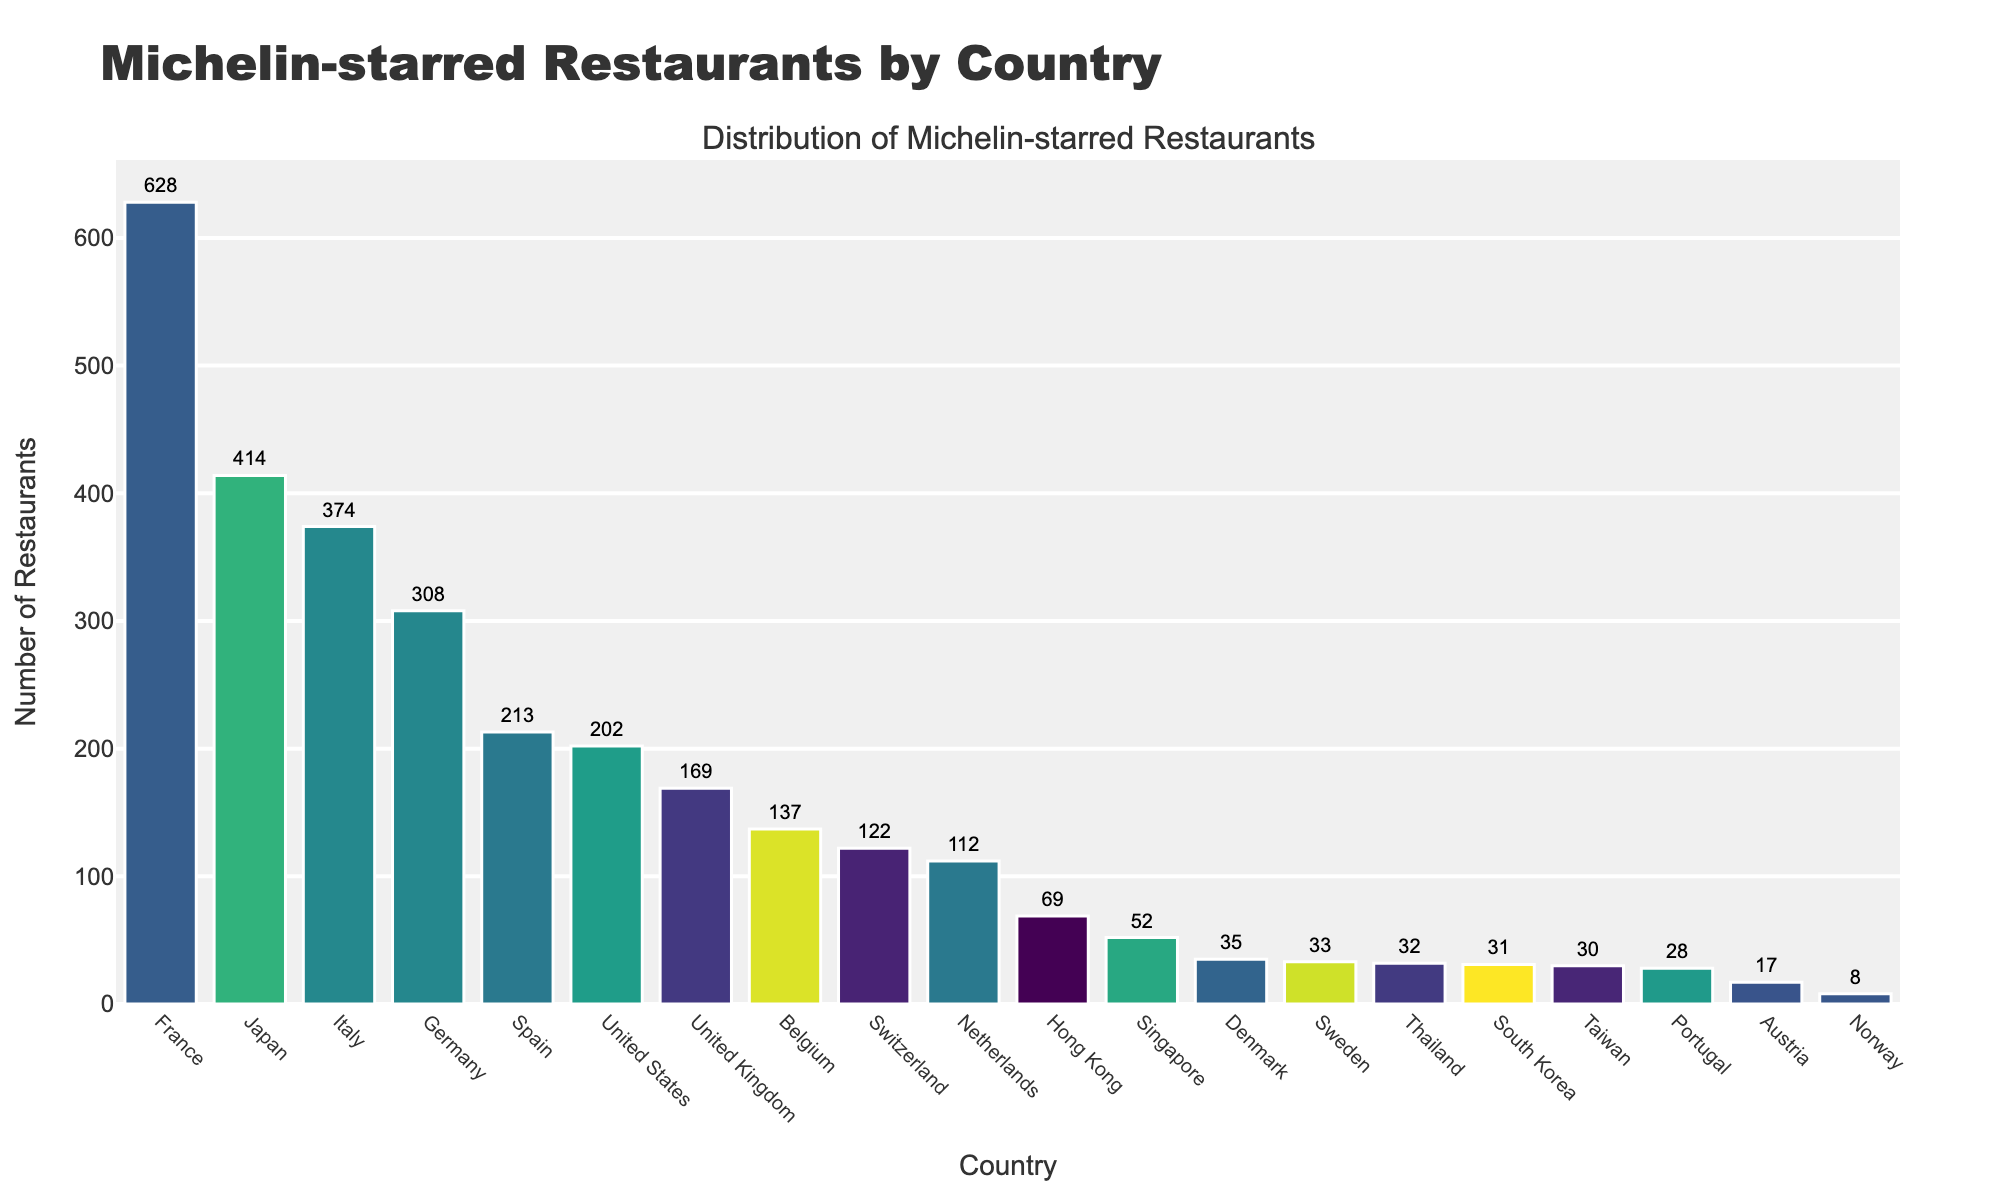Which country has the most Michelin-starred restaurants? The highest bar represents the country with the most Michelin-starred restaurants, which is labeled as 'France' with 628 restaurants.
Answer: France Which country has the fewest Michelin-starred restaurants? The shortest bar represents the country with the fewest Michelin-starred restaurants, which is labeled as 'Norway' with 8 restaurants.
Answer: Norway How many more Michelin-starred restaurants does France have compared to Japan? France has 628 restaurants, and Japan has 414. The difference is 628 - 414 = 214.
Answer: 214 Identify the countries with more than 200 Michelin-starred restaurants. By looking at the bars exceeding 200 on the y-axis, the countries are France (628), Japan (414), Italy (374), Germany (308), Spain (213), and the United States (202).
Answer: France, Japan, Italy, Germany, Spain, United States What is the total number of Michelin-starred restaurants in the top 3 countries? The top 3 countries are France (628), Japan (414), and Italy (374). The sum is 628 + 414 + 374 = 1416.
Answer: 1416 Which country has almost as many Michelin-starred restaurants as the United States? The United States has 202 restaurants. Spain has 213, which is close in number to the United States.
Answer: Spain How many more Michelin-starred restaurants are in France compared to the United Kingdom? France has 628 restaurants, and the United Kingdom has 169. The difference is 628 - 169 = 459.
Answer: 459 Which Scandinavian country has the highest number of Michelin-starred restaurants? Among Denmark, Sweden, and Norway, Denmark has the highest number with 35 restaurants.
Answer: Denmark 